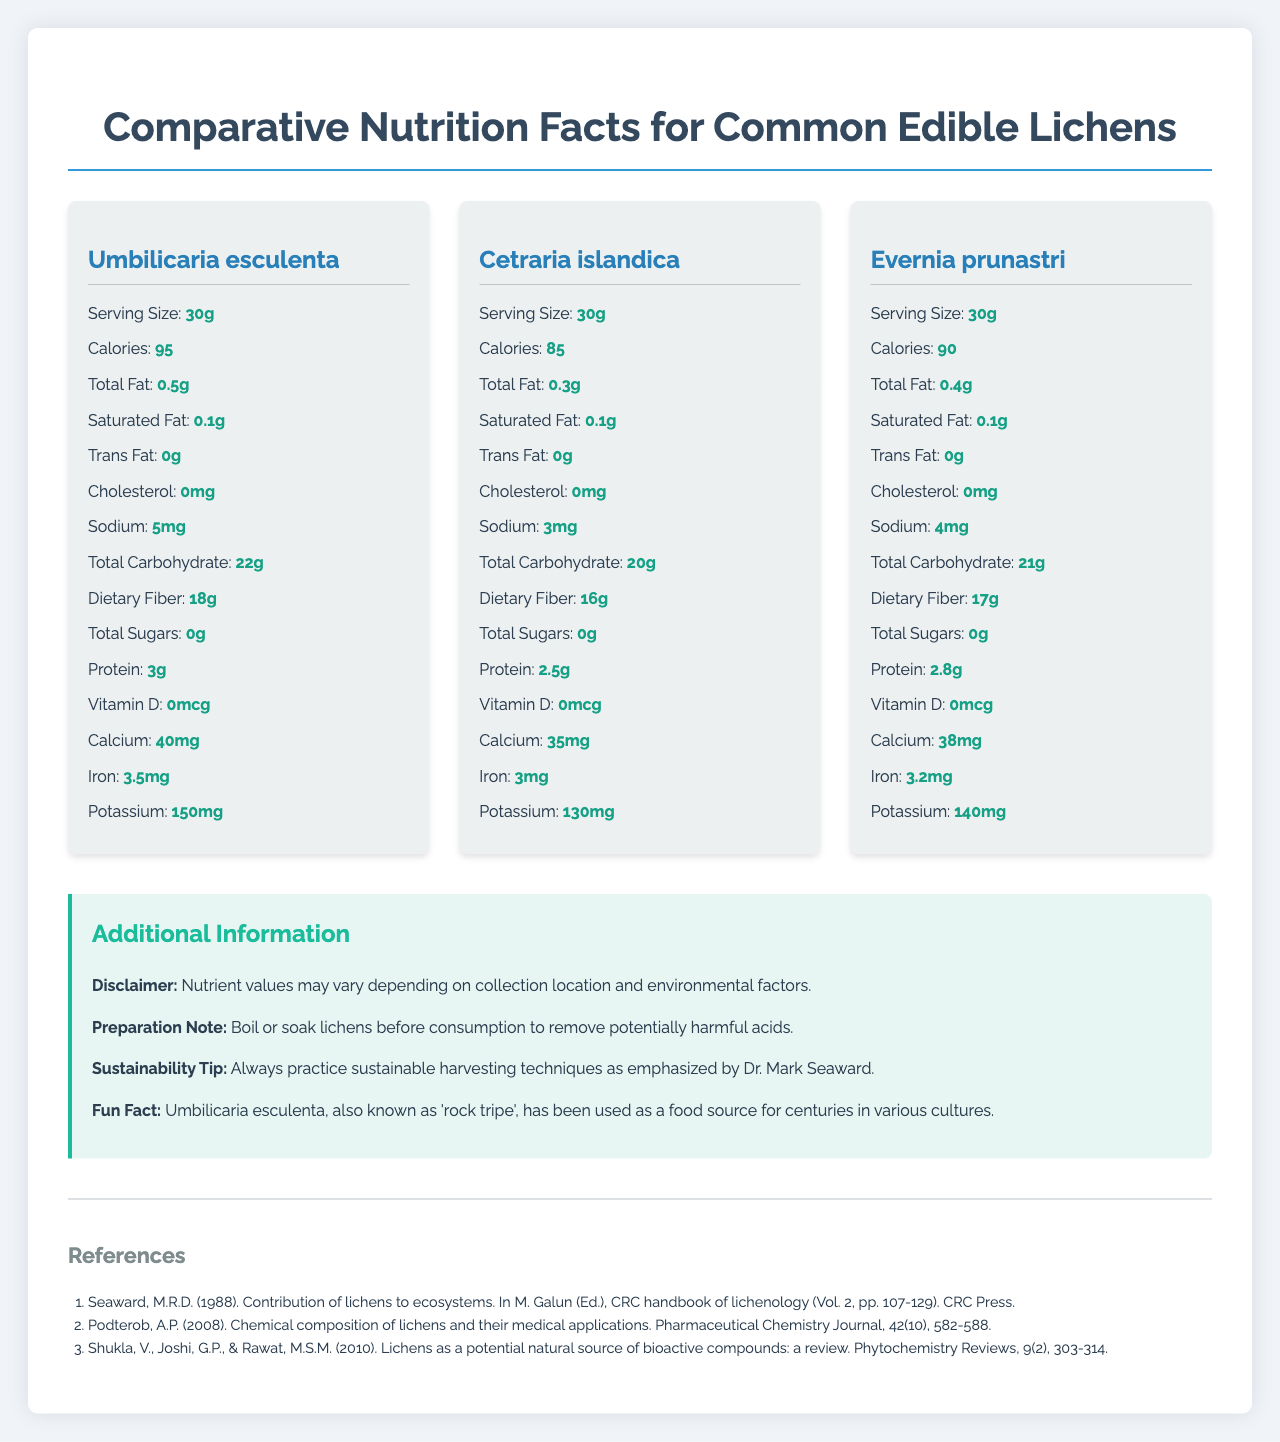what is the serving size of Umbilicaria esculenta? The document states that the serving size for Umbilicaria esculenta is 30 grams.
Answer: 30g how many calories are in a 30g serving of Cetraria islandica? The document mentions that Cetraria islandica has 85 calories per 30g serving.
Answer: 85 which lichen has the highest protein content? The document lists the protein contents as 3g for Umbilicaria esculenta, 2.5g for Cetraria islandica, and 2.8g for Evernia prunastri. Thus, Umbilicaria esculenta has the highest protein content.
Answer: Umbilicaria esculenta how many grams of dietary fiber are in a serving of Evernia prunastri? The document states that Evernia prunastri contains 17 grams of dietary fiber per 30g serving.
Answer: 17g which lichen contains the most potassium? Based on the document, Umbilicaria esculenta contains 150mg of potassium, which is higher than the potassium content of the other lichens listed.
Answer: Umbilicaria esculenta which lichen has the most calories per 30g serving? A. Umbilicaria esculenta B. Cetraria islandica C. Evernia prunastri The document states Umbilicaria esculenta has 95 calories, Cetraria islandica has 85 calories, and Evernia prunastri has 90 calories per 30g serving. Thus, Umbilicaria esculenta has the most calories per serving.
Answer: A which lichen has the least sodium content? I. Umbilicaria esculenta II. Cetraria islandica III. Evernia prunastri The document lists the sodium content as 5mg for Umbilicaria esculenta, 3mg for Cetraria islandica, and 4mg for Evernia prunastri. Therefore, Cetraria islandica has the least sodium content.
Answer: II should lichens be boiled or soaked before consumption? The preparation note in the document advises boiling or soaking lichens before consumption to remove potentially harmful acids.
Answer: Yes is there a disclaimer about the nutrient values in the document? The document includes a disclaimer stating that nutrient values may vary depending on collection location and environmental factors.
Answer: Yes describe the main idea of the document. The document outlines detailed nutritional information for Umbilicaria esculenta, Cetraria islandica, and Evernia prunastri, including calories, macronutrients, and micronutrients. It also includes preparation advice, sustainability practices promoted by Dr. Mark Seaward, and a fun historical fact about one of the lichens.
Answer: The document provides a comprehensive comparison of the nutritional content of three common edible lichens, with additional information on preparation methods, sustainability tips, and a fun fact. what is the antioxidant content of Evernia prunastri? The document does not provide any information about the antioxidant content of Evernia prunastri or any other lichens.
Answer: Not enough information 